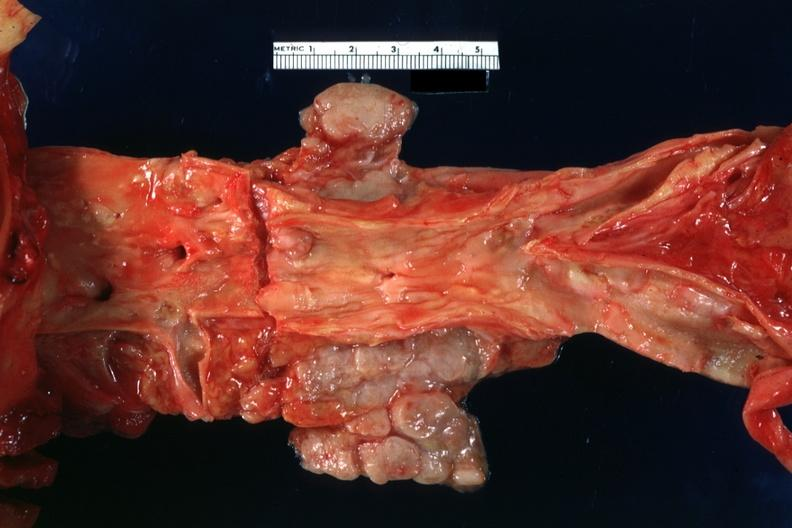does periaortic nodes with metastatic carcinoma aorta show good atherosclerotic plaques?
Answer the question using a single word or phrase. Yes 